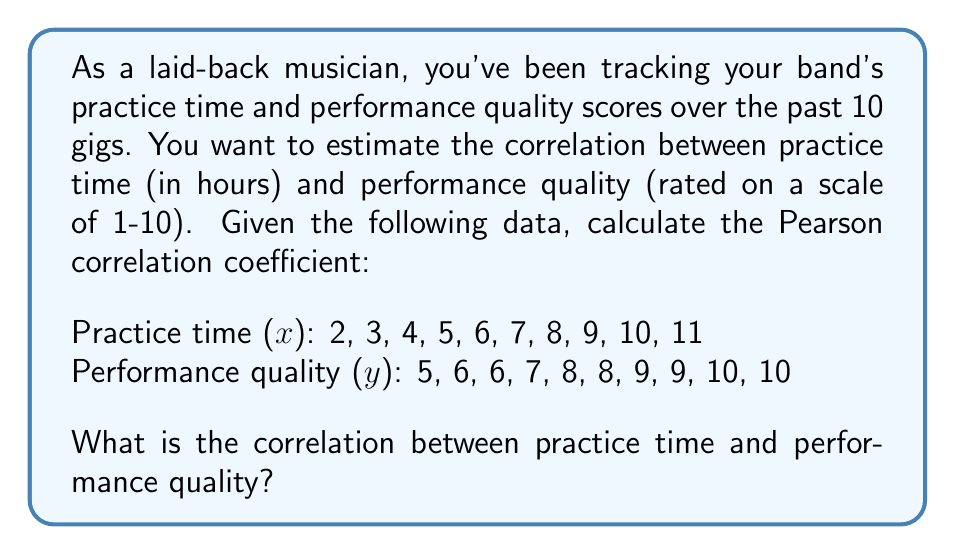Help me with this question. To calculate the Pearson correlation coefficient (r), we'll use the formula:

$$ r = \frac{n\sum xy - (\sum x)(\sum y)}{\sqrt{[n\sum x^2 - (\sum x)^2][n\sum y^2 - (\sum y)^2]}} $$

Step 1: Calculate the sums and squared sums:
$\sum x = 65$
$\sum y = 78$
$\sum x^2 = 507$
$\sum y^2 = 630$
$\sum xy = 545$
$n = 10$

Step 2: Plug these values into the formula:

$$ r = \frac{10(545) - (65)(78)}{\sqrt{[10(507) - 65^2][10(630) - 78^2]}} $$

Step 3: Simplify:

$$ r = \frac{5450 - 5070}{\sqrt{(5070 - 4225)(6300 - 6084)}} $$

$$ r = \frac{380}{\sqrt{845 \times 216}} $$

$$ r = \frac{380}{\sqrt{182520}} $$

$$ r = \frac{380}{427.22} $$

Step 4: Calculate the final result:

$$ r \approx 0.8895 $$
Answer: $0.8895$ 